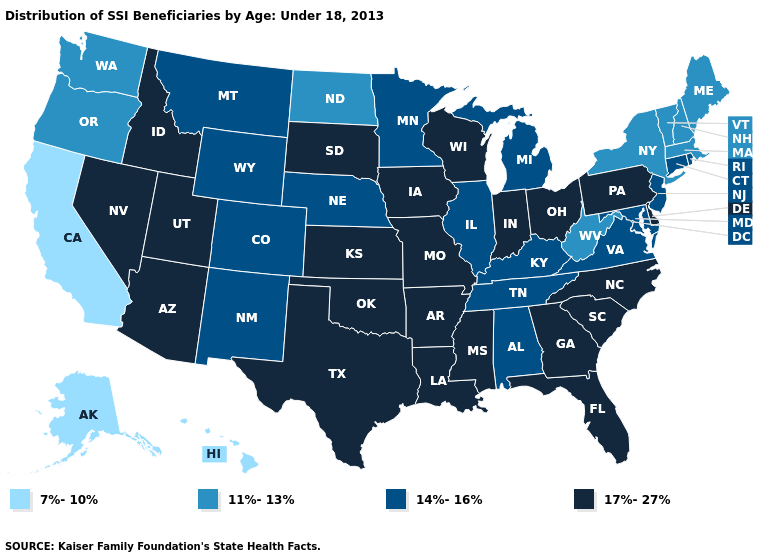What is the highest value in the West ?
Give a very brief answer. 17%-27%. What is the value of Montana?
Short answer required. 14%-16%. What is the value of Nebraska?
Be succinct. 14%-16%. Which states have the lowest value in the USA?
Short answer required. Alaska, California, Hawaii. Name the states that have a value in the range 7%-10%?
Answer briefly. Alaska, California, Hawaii. Name the states that have a value in the range 17%-27%?
Keep it brief. Arizona, Arkansas, Delaware, Florida, Georgia, Idaho, Indiana, Iowa, Kansas, Louisiana, Mississippi, Missouri, Nevada, North Carolina, Ohio, Oklahoma, Pennsylvania, South Carolina, South Dakota, Texas, Utah, Wisconsin. How many symbols are there in the legend?
Quick response, please. 4. Name the states that have a value in the range 14%-16%?
Answer briefly. Alabama, Colorado, Connecticut, Illinois, Kentucky, Maryland, Michigan, Minnesota, Montana, Nebraska, New Jersey, New Mexico, Rhode Island, Tennessee, Virginia, Wyoming. Does Arizona have the same value as Maine?
Keep it brief. No. Name the states that have a value in the range 7%-10%?
Give a very brief answer. Alaska, California, Hawaii. Does Arizona have the highest value in the USA?
Quick response, please. Yes. Name the states that have a value in the range 17%-27%?
Quick response, please. Arizona, Arkansas, Delaware, Florida, Georgia, Idaho, Indiana, Iowa, Kansas, Louisiana, Mississippi, Missouri, Nevada, North Carolina, Ohio, Oklahoma, Pennsylvania, South Carolina, South Dakota, Texas, Utah, Wisconsin. Which states hav the highest value in the MidWest?
Quick response, please. Indiana, Iowa, Kansas, Missouri, Ohio, South Dakota, Wisconsin. What is the value of Wyoming?
Give a very brief answer. 14%-16%. What is the lowest value in states that border Oregon?
Keep it brief. 7%-10%. 